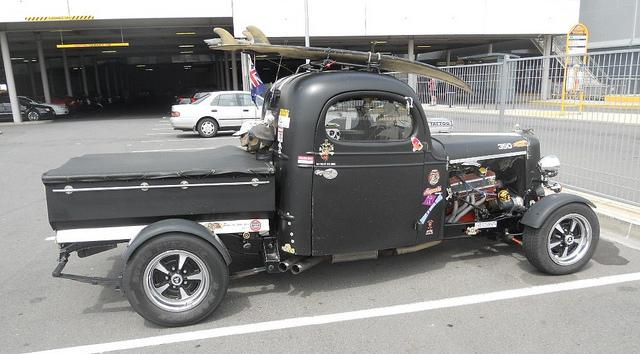What hobby does the car owner enjoy?

Choices:
A) skating
B) painting
C) surfing
D) biking surfing 